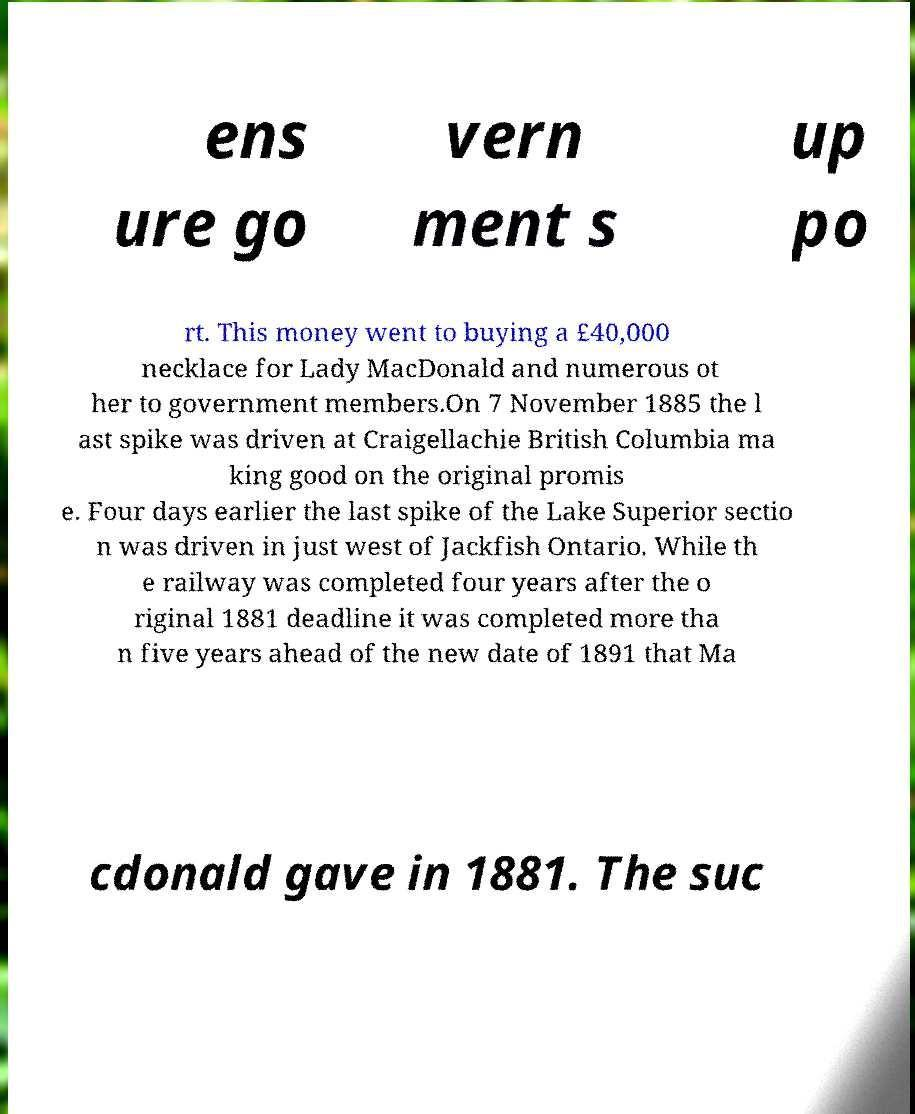For documentation purposes, I need the text within this image transcribed. Could you provide that? ens ure go vern ment s up po rt. This money went to buying a £40,000 necklace for Lady MacDonald and numerous ot her to government members.On 7 November 1885 the l ast spike was driven at Craigellachie British Columbia ma king good on the original promis e. Four days earlier the last spike of the Lake Superior sectio n was driven in just west of Jackfish Ontario. While th e railway was completed four years after the o riginal 1881 deadline it was completed more tha n five years ahead of the new date of 1891 that Ma cdonald gave in 1881. The suc 